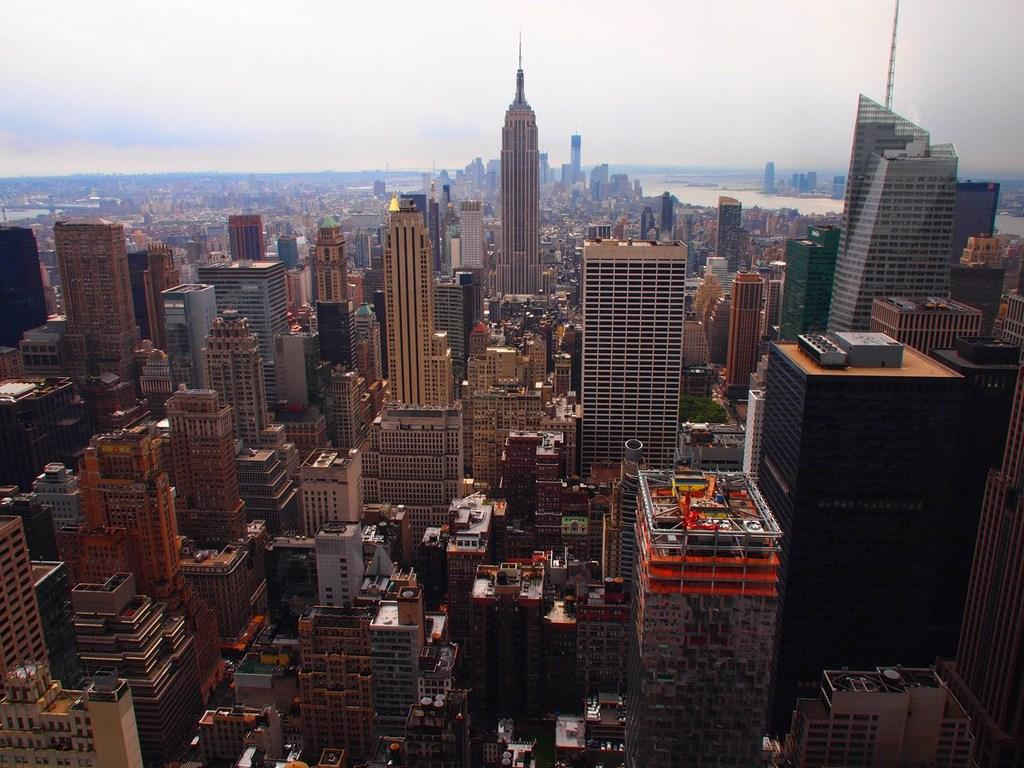What type of structures can be seen in the image? There are buildings in the image. What natural element is present in the image? There is a tree in the image. What can be seen in the water in the image? The water is visible in the image, but no specific details about its contents are provided. What part of the natural environment is visible in the image? The sky is visible in the image. How many police officers are riding bikes in the image? There are no police officers or bikes present in the image. What rule is being enforced by the person in the image? There is no person or rule-enforcing activity depicted in the image. 